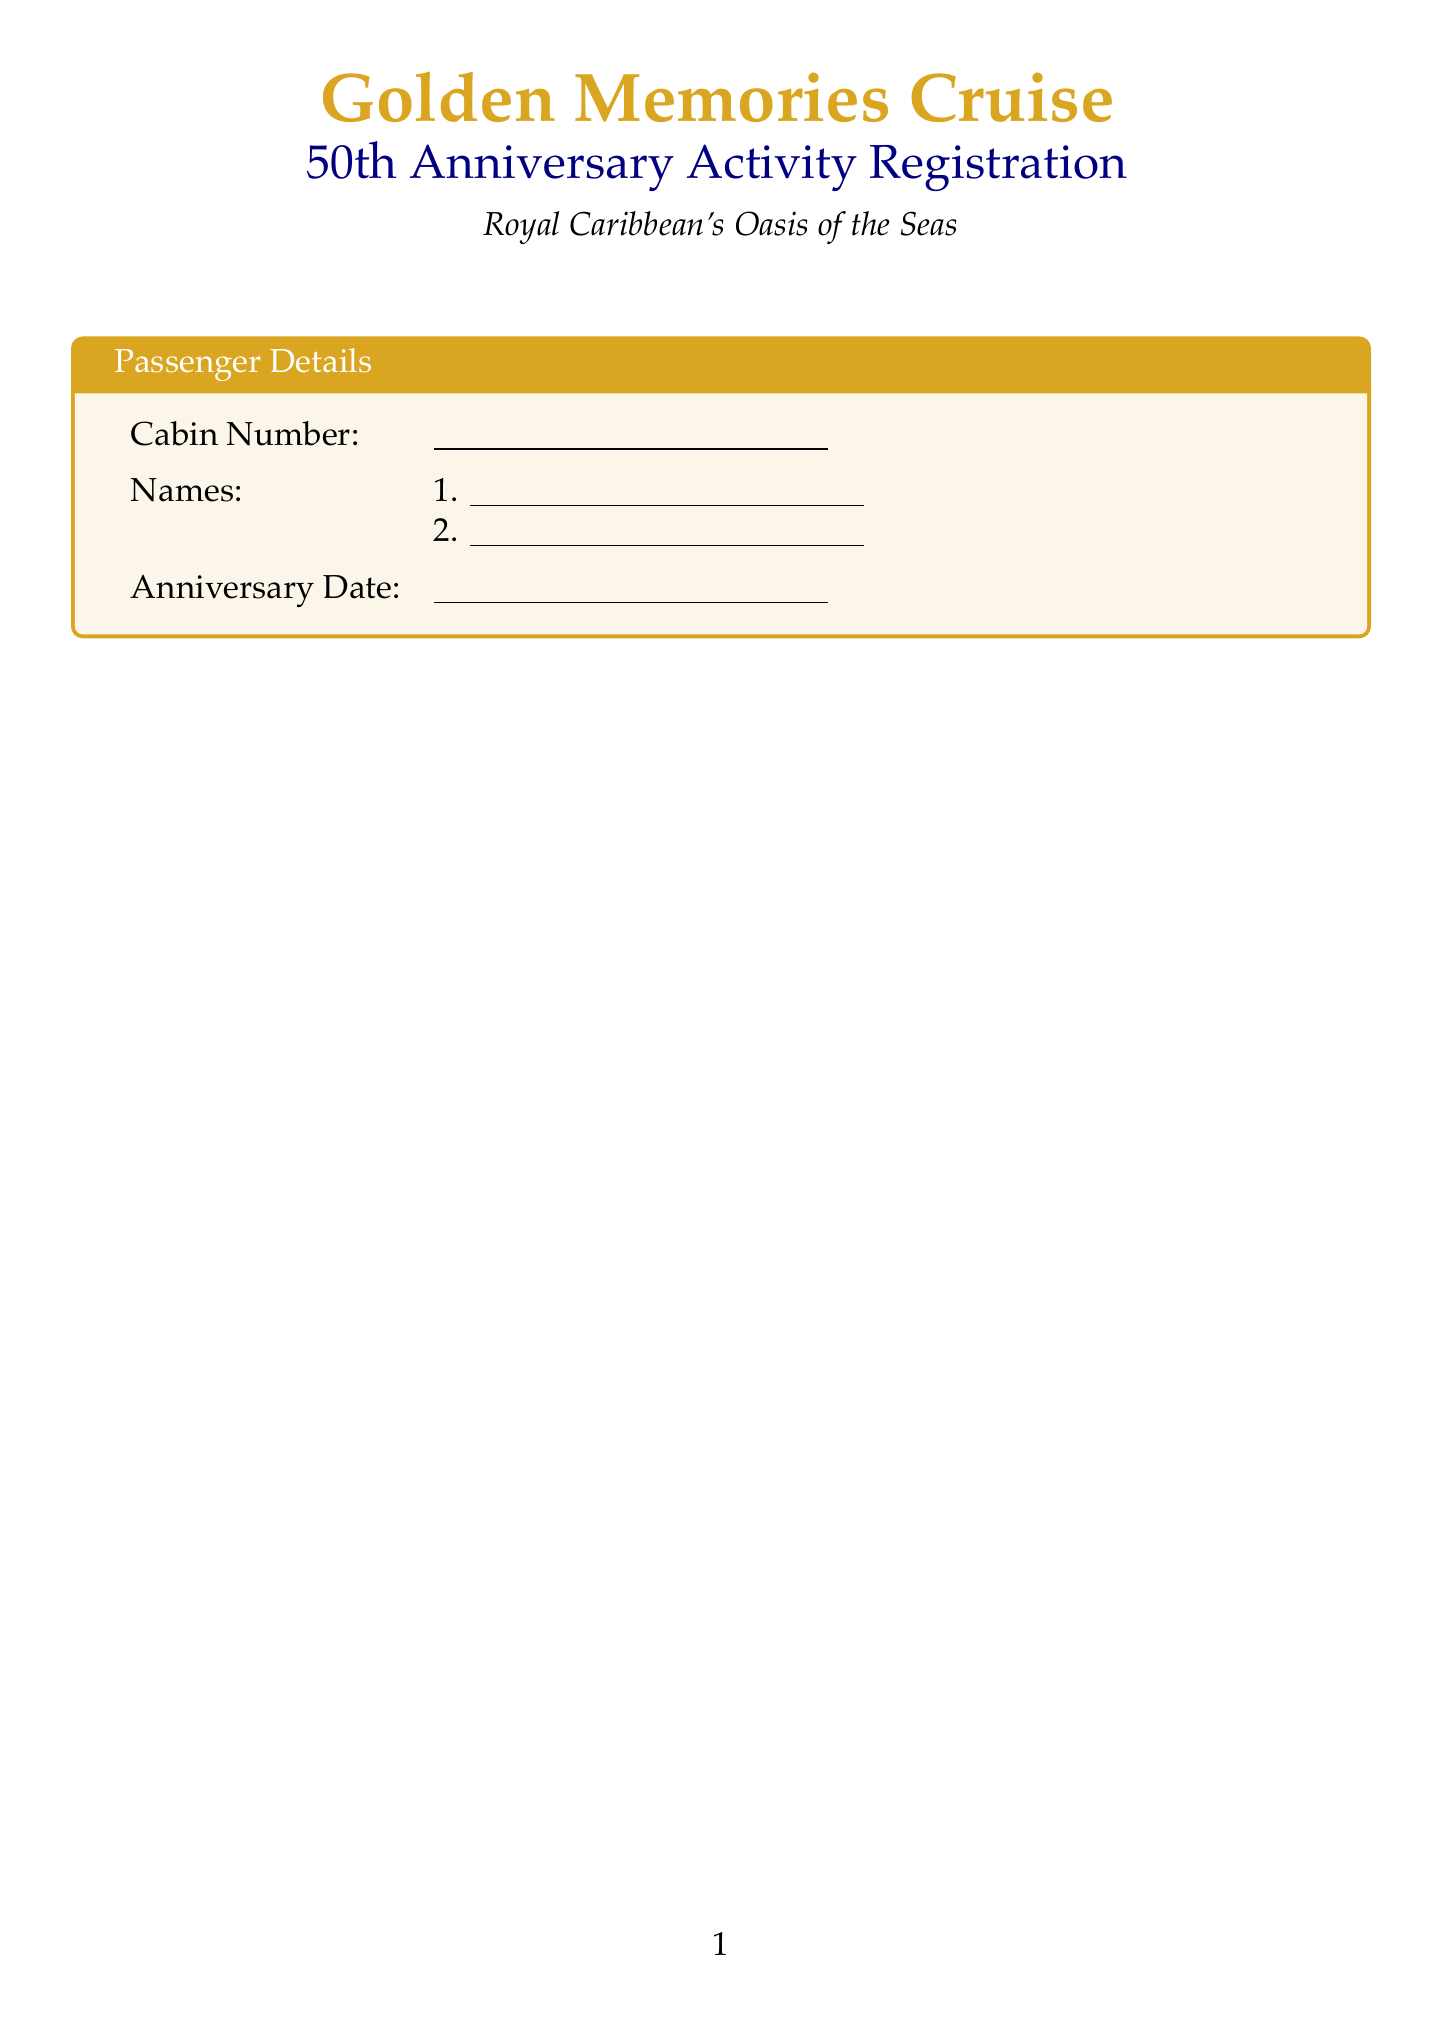What is the title of the registration form? The title of the registration form is displayed prominently at the top of the document, which is "Golden Memories Cruise: 50th Anniversary Activity Registration."
Answer: Golden Memories Cruise: 50th Anniversary Activity Registration What is the name of the cruise ship? The name of the cruise ship is mentioned in the document as part of the title, which is "Royal Caribbean's Oasis of the Seas."
Answer: Royal Caribbean's Oasis of the Seas What time does the "Waltz Under the Stars" activity start? The document provides detailed timing for the activities, stating that "Waltz Under the Stars" starts at 7:00 PM.
Answer: 7:00 PM Who is the chef for the "Mediterranean Delights" cooking class? The cooking classes section mentions the chef's name for "Mediterranean Delights," which is "Chef Maria Rossi."
Answer: Chef Maria Rossi What is the duration of the "Historic San Juan Walking Tour"? The duration for the sightseeing tour is listed in the document, specifying that it lasts for "3 hours."
Answer: 3 hours Which activity is described as "Beginner-Friendly"? The description states that "Waltz Under the Stars" is characterized as "Beginner-Friendly."
Answer: Waltz Under the Stars What is the dietary restrictions section for? The document includes a section for personal information, specifying the dietary restrictions for passengers.
Answer: Dietary restrictions How many activities are offered under "Sightseeing Tours"? The document lists two specific activities under the "Sightseeing Tours" category.
Answer: 2 What must participants do to cancel an activity for a full refund? The cancellation policy is clarified in the terms section, indicating participants must provide cancellations "24 hours in advance."
Answer: 24 hours in advance 